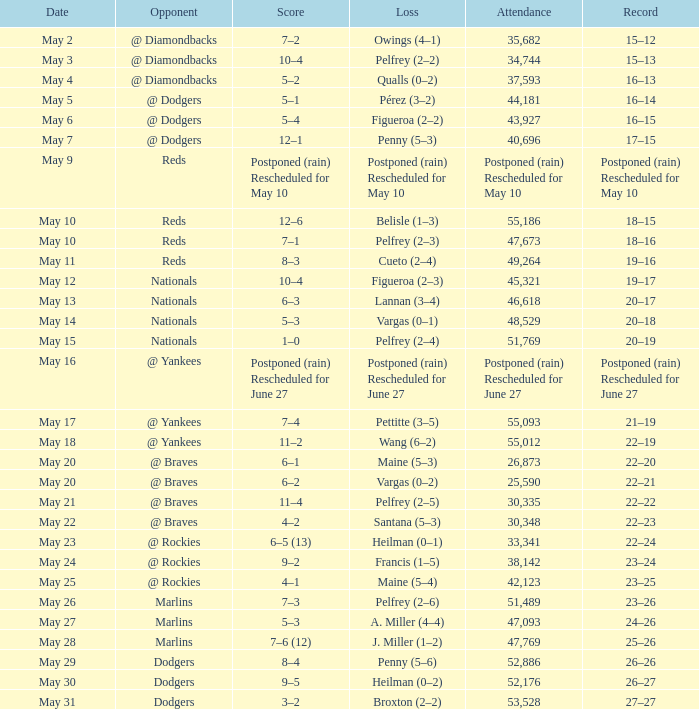Regarding the loss postponed (due to rain) and rescheduled for may 10, what was the record? Postponed (rain) Rescheduled for May 10. 